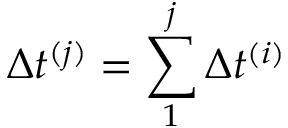<formula> <loc_0><loc_0><loc_500><loc_500>\Delta t ^ { ( j ) } = \sum _ { 1 } ^ { j } \Delta t ^ { ( i ) }</formula> 